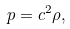<formula> <loc_0><loc_0><loc_500><loc_500>p = c ^ { 2 } \rho ,</formula> 